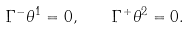<formula> <loc_0><loc_0><loc_500><loc_500>\Gamma ^ { - } \theta ^ { 1 } = 0 , \quad \Gamma ^ { + } \theta ^ { 2 } = 0 .</formula> 